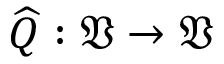Convert formula to latex. <formula><loc_0><loc_0><loc_500><loc_500>\widehat { Q } \colon \mathfrak { V } \to \mathfrak { V }</formula> 